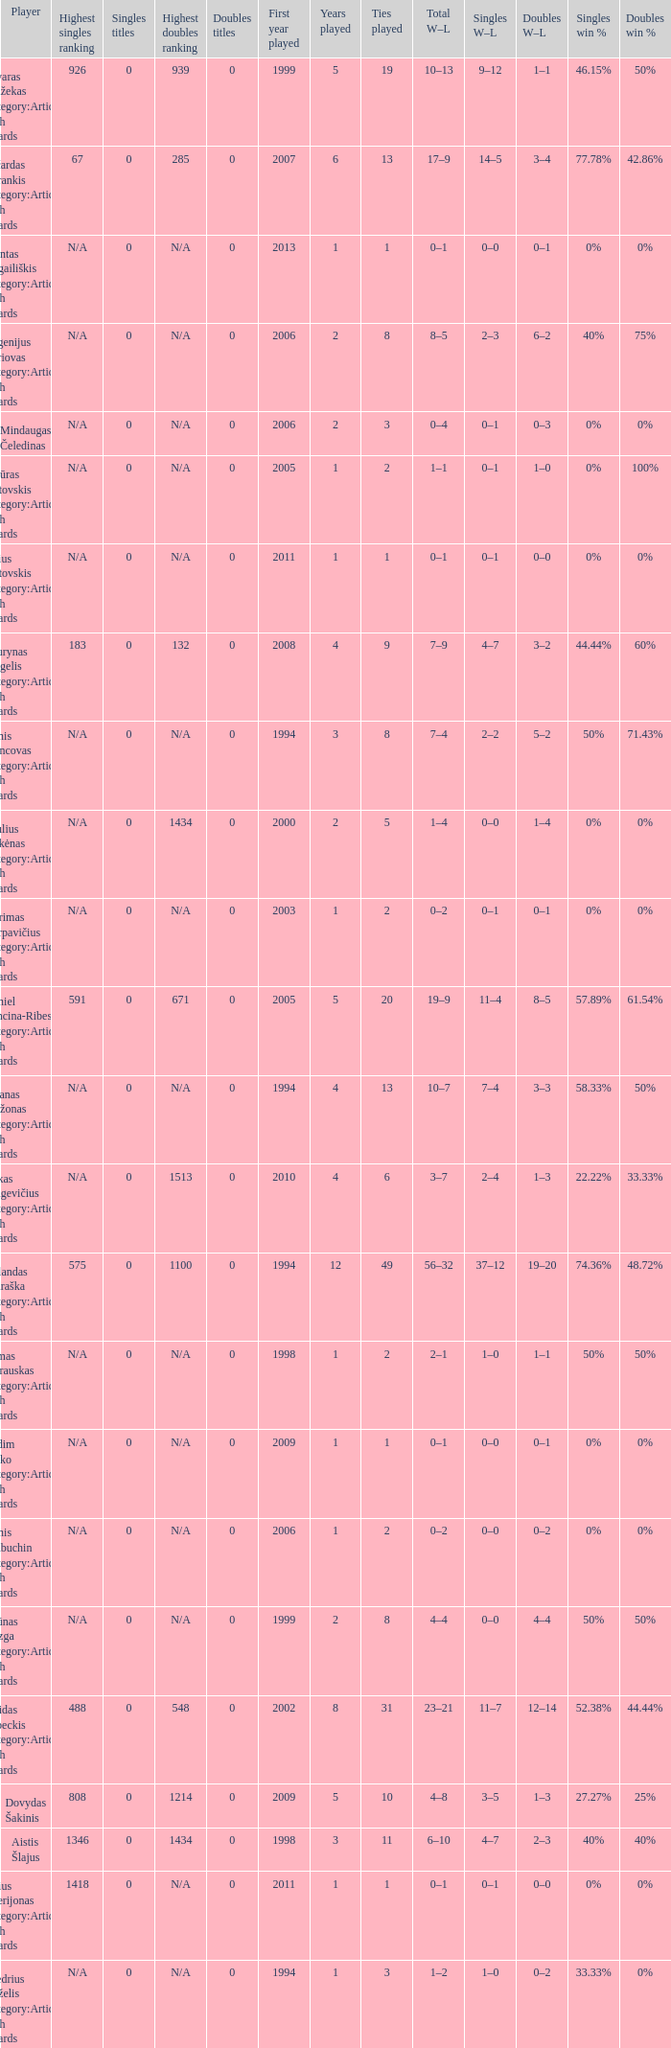Name the minimum tiesplayed for 6 years 13.0. 